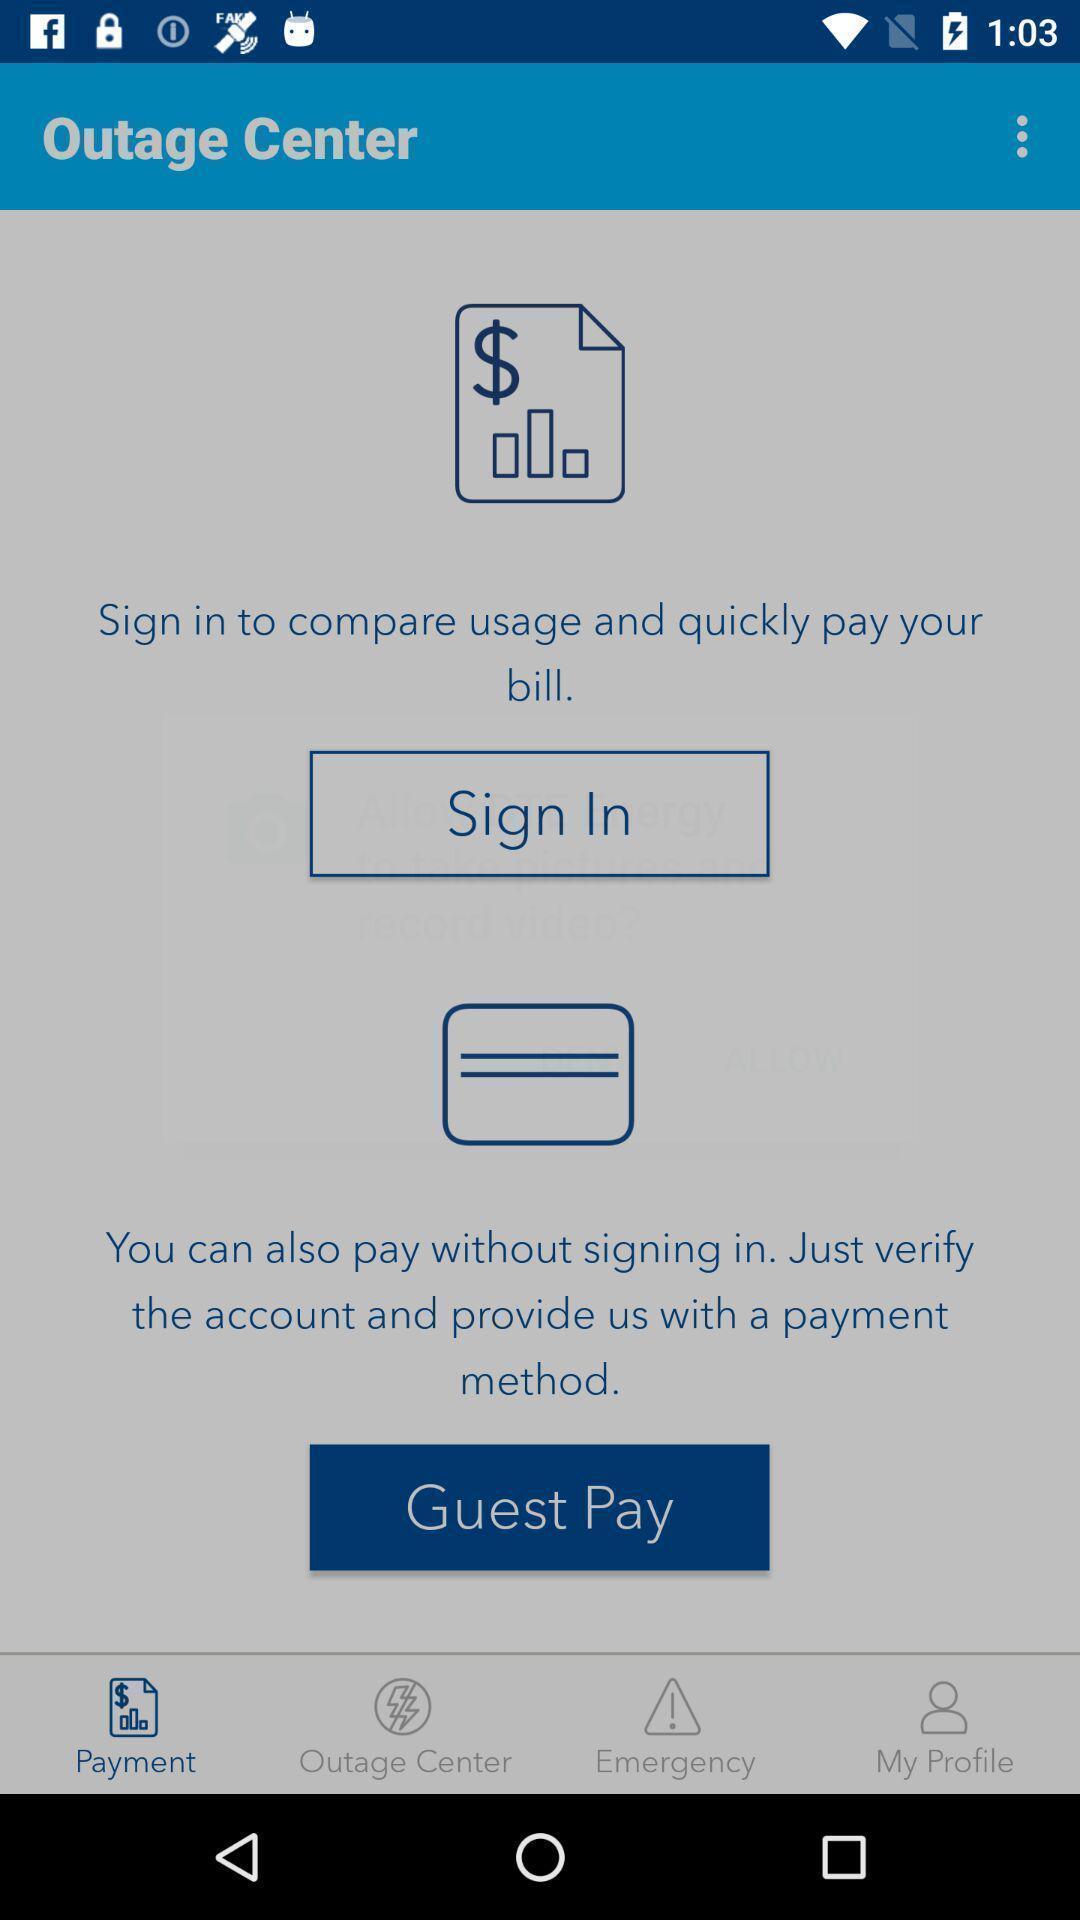Provide a detailed account of this screenshot. Sign in page. 